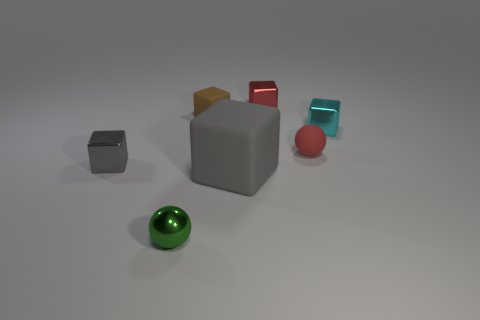Subtract all small brown rubber cubes. How many cubes are left? 4 Subtract 2 spheres. How many spheres are left? 0 Add 2 tiny brown blocks. How many objects exist? 9 Subtract all green balls. How many balls are left? 1 Subtract all red objects. Subtract all blue balls. How many objects are left? 5 Add 5 tiny red metal objects. How many tiny red metal objects are left? 6 Add 5 tiny rubber blocks. How many tiny rubber blocks exist? 6 Subtract 1 red cubes. How many objects are left? 6 Subtract all cubes. How many objects are left? 2 Subtract all brown cubes. Subtract all yellow cylinders. How many cubes are left? 4 